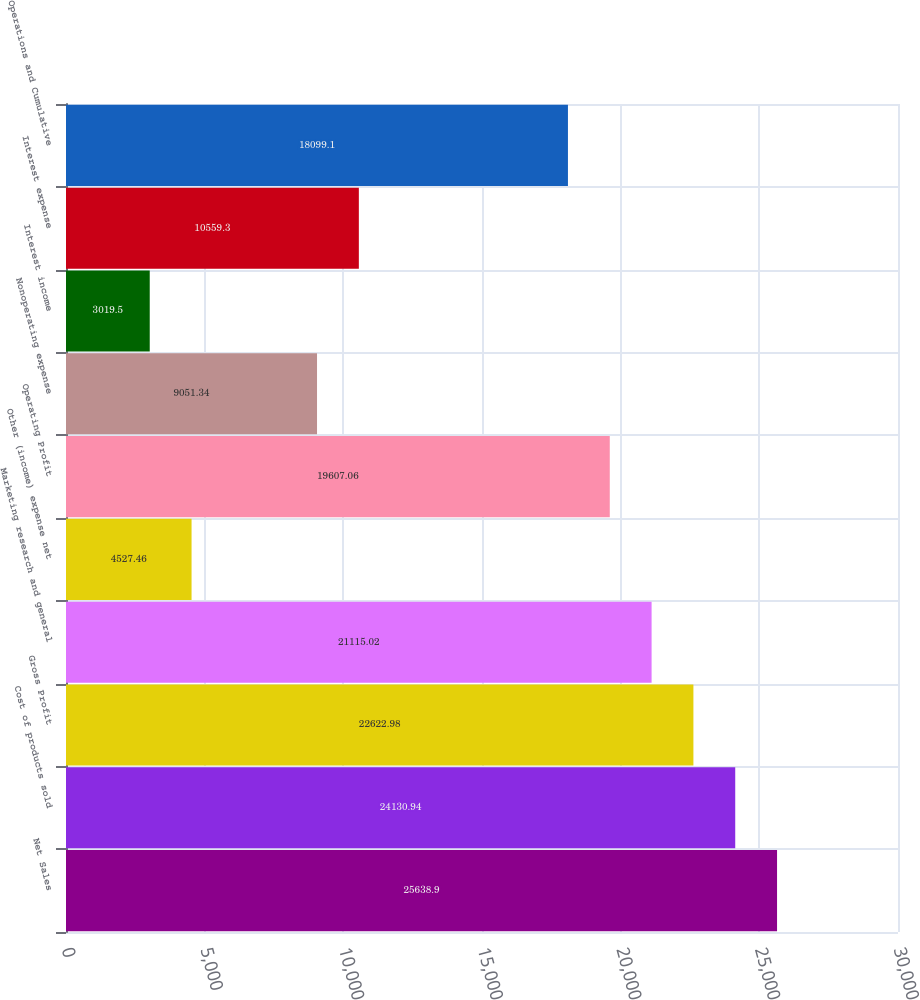<chart> <loc_0><loc_0><loc_500><loc_500><bar_chart><fcel>Net Sales<fcel>Cost of products sold<fcel>Gross Profit<fcel>Marketing research and general<fcel>Other (income) expense net<fcel>Operating Profit<fcel>Nonoperating expense<fcel>Interest income<fcel>Interest expense<fcel>Operations and Cumulative<nl><fcel>25638.9<fcel>24130.9<fcel>22623<fcel>21115<fcel>4527.46<fcel>19607.1<fcel>9051.34<fcel>3019.5<fcel>10559.3<fcel>18099.1<nl></chart> 